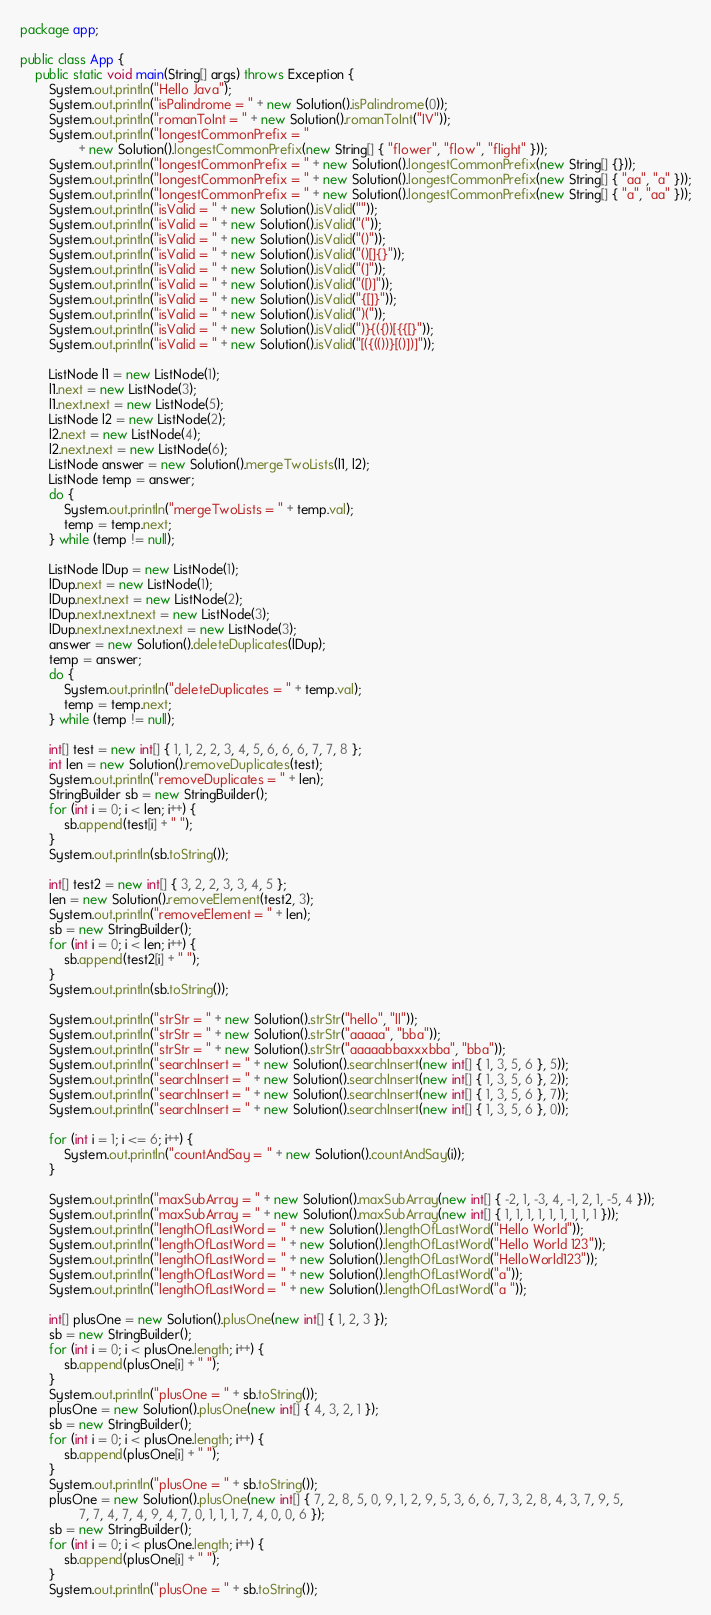<code> <loc_0><loc_0><loc_500><loc_500><_Java_>package app;

public class App {
    public static void main(String[] args) throws Exception {
        System.out.println("Hello Java");
        System.out.println("isPalindrome = " + new Solution().isPalindrome(0));
        System.out.println("romanToInt = " + new Solution().romanToInt("IV"));
        System.out.println("longestCommonPrefix = "
                + new Solution().longestCommonPrefix(new String[] { "flower", "flow", "flight" }));
        System.out.println("longestCommonPrefix = " + new Solution().longestCommonPrefix(new String[] {}));
        System.out.println("longestCommonPrefix = " + new Solution().longestCommonPrefix(new String[] { "aa", "a" }));
        System.out.println("longestCommonPrefix = " + new Solution().longestCommonPrefix(new String[] { "a", "aa" }));
        System.out.println("isValid = " + new Solution().isValid(""));
        System.out.println("isValid = " + new Solution().isValid("("));
        System.out.println("isValid = " + new Solution().isValid("()"));
        System.out.println("isValid = " + new Solution().isValid("()[]{}"));
        System.out.println("isValid = " + new Solution().isValid("(]"));
        System.out.println("isValid = " + new Solution().isValid("([)]"));
        System.out.println("isValid = " + new Solution().isValid("{[]}"));
        System.out.println("isValid = " + new Solution().isValid(")("));
        System.out.println("isValid = " + new Solution().isValid(")}{({))[{{[}"));
        System.out.println("isValid = " + new Solution().isValid("[({(())}[()])]"));

        ListNode l1 = new ListNode(1);
        l1.next = new ListNode(3);
        l1.next.next = new ListNode(5);
        ListNode l2 = new ListNode(2);
        l2.next = new ListNode(4);
        l2.next.next = new ListNode(6);
        ListNode answer = new Solution().mergeTwoLists(l1, l2);
        ListNode temp = answer;
        do {
            System.out.println("mergeTwoLists = " + temp.val);
            temp = temp.next;
        } while (temp != null);

        ListNode lDup = new ListNode(1);
        lDup.next = new ListNode(1);
        lDup.next.next = new ListNode(2);
        lDup.next.next.next = new ListNode(3);
        lDup.next.next.next.next = new ListNode(3);
        answer = new Solution().deleteDuplicates(lDup);
        temp = answer;
        do {
            System.out.println("deleteDuplicates = " + temp.val);
            temp = temp.next;
        } while (temp != null);

        int[] test = new int[] { 1, 1, 2, 2, 3, 4, 5, 6, 6, 6, 7, 7, 8 };
        int len = new Solution().removeDuplicates(test);
        System.out.println("removeDuplicates = " + len);
        StringBuilder sb = new StringBuilder();
        for (int i = 0; i < len; i++) {
            sb.append(test[i] + " ");
        }
        System.out.println(sb.toString());

        int[] test2 = new int[] { 3, 2, 2, 3, 3, 4, 5 };
        len = new Solution().removeElement(test2, 3);
        System.out.println("removeElement = " + len);
        sb = new StringBuilder();
        for (int i = 0; i < len; i++) {
            sb.append(test2[i] + " ");
        }
        System.out.println(sb.toString());

        System.out.println("strStr = " + new Solution().strStr("hello", "ll"));
        System.out.println("strStr = " + new Solution().strStr("aaaaa", "bba"));
        System.out.println("strStr = " + new Solution().strStr("aaaaabbaxxxbba", "bba"));
        System.out.println("searchInsert = " + new Solution().searchInsert(new int[] { 1, 3, 5, 6 }, 5));
        System.out.println("searchInsert = " + new Solution().searchInsert(new int[] { 1, 3, 5, 6 }, 2));
        System.out.println("searchInsert = " + new Solution().searchInsert(new int[] { 1, 3, 5, 6 }, 7));
        System.out.println("searchInsert = " + new Solution().searchInsert(new int[] { 1, 3, 5, 6 }, 0));

        for (int i = 1; i <= 6; i++) {
            System.out.println("countAndSay = " + new Solution().countAndSay(i));
        }

        System.out.println("maxSubArray = " + new Solution().maxSubArray(new int[] { -2, 1, -3, 4, -1, 2, 1, -5, 4 }));
        System.out.println("maxSubArray = " + new Solution().maxSubArray(new int[] { 1, 1, 1, 1, 1, 1, 1, 1, 1 }));
        System.out.println("lengthOfLastWord = " + new Solution().lengthOfLastWord("Hello World"));
        System.out.println("lengthOfLastWord = " + new Solution().lengthOfLastWord("Hello World 123"));
        System.out.println("lengthOfLastWord = " + new Solution().lengthOfLastWord("HelloWorld123"));
        System.out.println("lengthOfLastWord = " + new Solution().lengthOfLastWord("a"));
        System.out.println("lengthOfLastWord = " + new Solution().lengthOfLastWord("a "));

        int[] plusOne = new Solution().plusOne(new int[] { 1, 2, 3 });
        sb = new StringBuilder();
        for (int i = 0; i < plusOne.length; i++) {
            sb.append(plusOne[i] + " ");
        }
        System.out.println("plusOne = " + sb.toString());
        plusOne = new Solution().plusOne(new int[] { 4, 3, 2, 1 });
        sb = new StringBuilder();
        for (int i = 0; i < plusOne.length; i++) {
            sb.append(plusOne[i] + " ");
        }
        System.out.println("plusOne = " + sb.toString());
        plusOne = new Solution().plusOne(new int[] { 7, 2, 8, 5, 0, 9, 1, 2, 9, 5, 3, 6, 6, 7, 3, 2, 8, 4, 3, 7, 9, 5,
                7, 7, 4, 7, 4, 9, 4, 7, 0, 1, 1, 1, 7, 4, 0, 0, 6 });
        sb = new StringBuilder();
        for (int i = 0; i < plusOne.length; i++) {
            sb.append(plusOne[i] + " ");
        }
        System.out.println("plusOne = " + sb.toString());</code> 